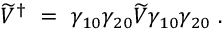<formula> <loc_0><loc_0><loc_500><loc_500>\widetilde { V } ^ { \dagger } \ = \ \gamma _ { 1 0 } \gamma _ { 2 0 } \widetilde { V } \gamma _ { 1 0 } \gamma _ { 2 0 } \ .</formula> 